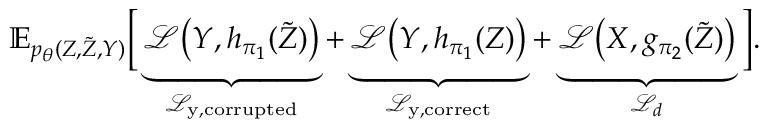Convert formula to latex. <formula><loc_0><loc_0><loc_500><loc_500>\mathbb { E } _ { p _ { \theta } ( Z , \tilde { Z } , Y ) } \left [ \underbrace { \mathcal { L } \left ( Y , h _ { \pi _ { 1 } } ( \tilde { Z } ) \right ) } _ { \mathcal { L } _ { y , c o r r u p t e d } } + \underbrace { \mathcal { L } \left ( Y , h _ { \pi _ { 1 } } ( Z ) \right ) } _ { \mathcal { L } _ { y , c o r r e c t } } + \underbrace { \mathcal { L } \left ( X , g _ { \pi _ { 2 } } ( \tilde { Z } ) \right ) } _ { \mathcal { L } _ { d } } \right ] .</formula> 